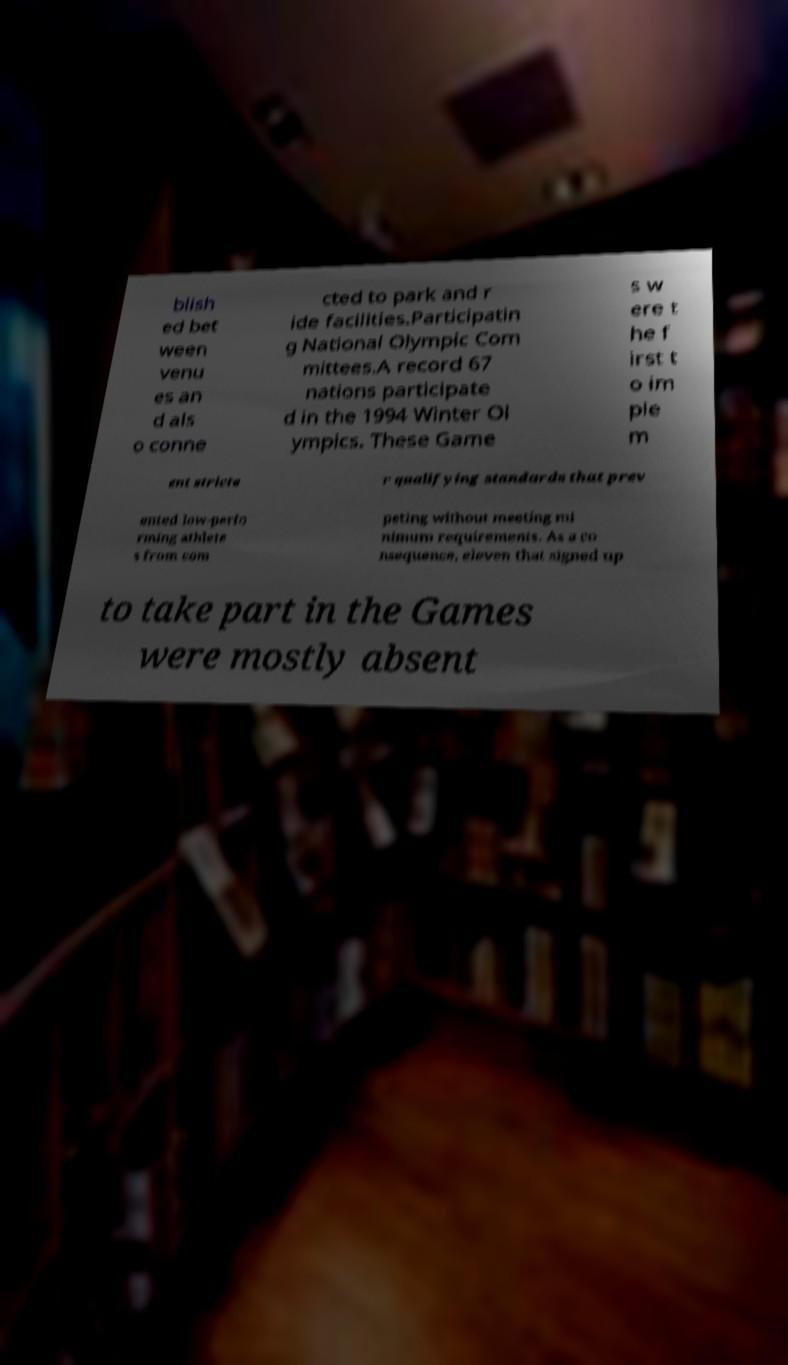There's text embedded in this image that I need extracted. Can you transcribe it verbatim? blish ed bet ween venu es an d als o conne cted to park and r ide facilities.Participatin g National Olympic Com mittees.A record 67 nations participate d in the 1994 Winter Ol ympics. These Game s w ere t he f irst t o im ple m ent stricte r qualifying standards that prev ented low-perfo rming athlete s from com peting without meeting mi nimum requirements. As a co nsequence, eleven that signed up to take part in the Games were mostly absent 